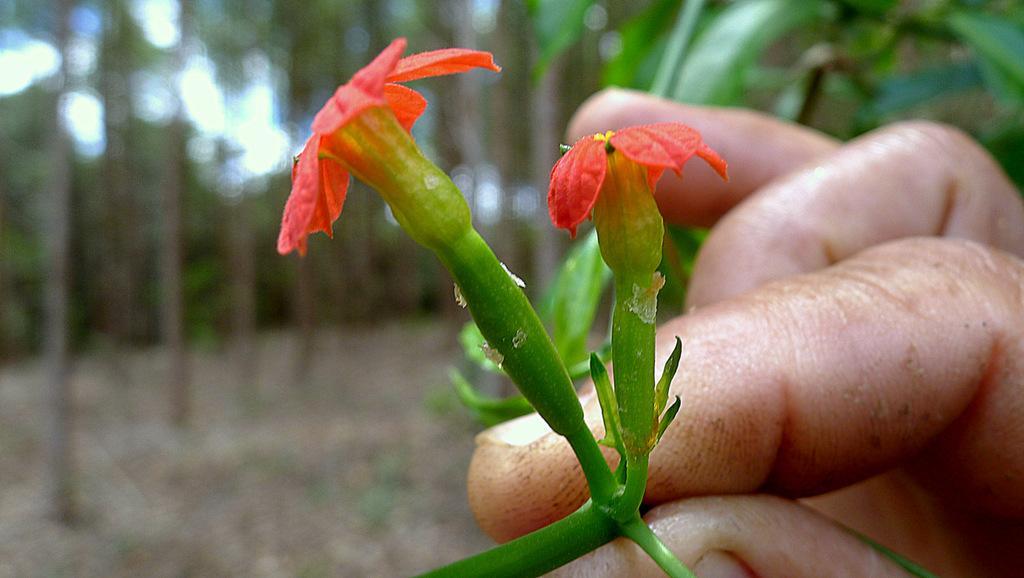Can you describe this image briefly? In the center of the image we can see the flowers in the hands of a person. In the background of the image trees are there. At the bottom of the image we can see the ground. 